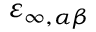<formula> <loc_0><loc_0><loc_500><loc_500>\varepsilon _ { \infty , \alpha \beta }</formula> 